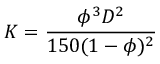Convert formula to latex. <formula><loc_0><loc_0><loc_500><loc_500>K = \frac { \phi ^ { 3 } D ^ { 2 } } { 1 5 0 ( 1 - \phi ) ^ { 2 } }</formula> 